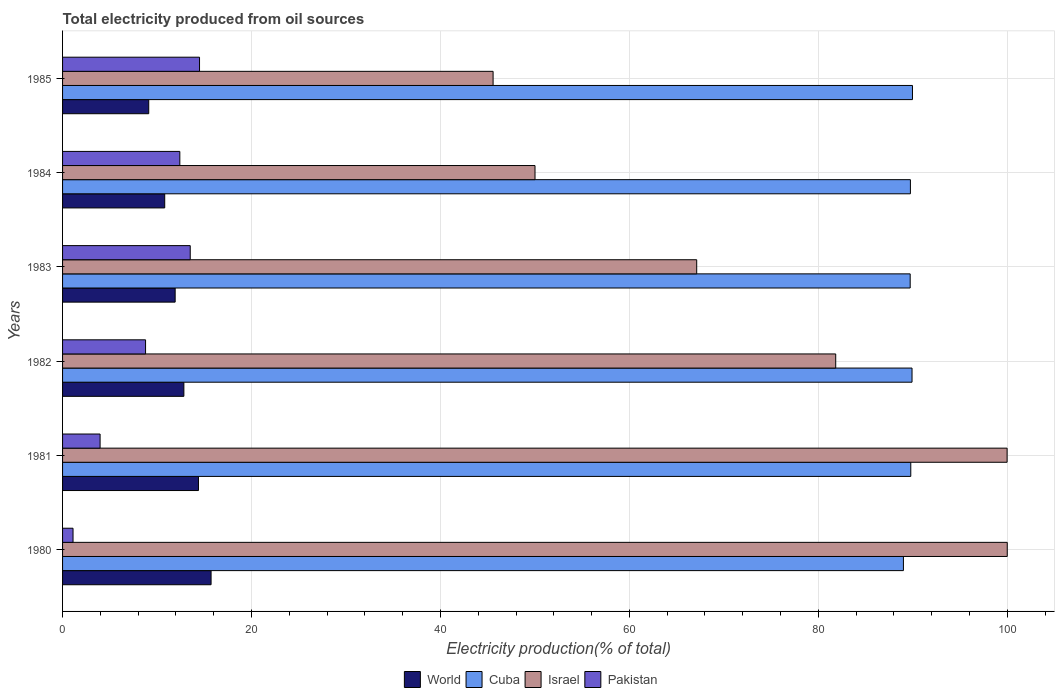How many different coloured bars are there?
Ensure brevity in your answer.  4. How many groups of bars are there?
Offer a terse response. 6. Are the number of bars on each tick of the Y-axis equal?
Your answer should be compact. Yes. How many bars are there on the 4th tick from the top?
Provide a succinct answer. 4. What is the total electricity produced in Israel in 1984?
Give a very brief answer. 50.01. Across all years, what is the maximum total electricity produced in World?
Your answer should be compact. 15.72. Across all years, what is the minimum total electricity produced in Pakistan?
Offer a very short reply. 1.11. In which year was the total electricity produced in Israel maximum?
Offer a terse response. 1980. In which year was the total electricity produced in World minimum?
Ensure brevity in your answer.  1985. What is the total total electricity produced in World in the graph?
Offer a very short reply. 74.8. What is the difference between the total electricity produced in Pakistan in 1983 and that in 1985?
Your response must be concise. -0.98. What is the difference between the total electricity produced in Israel in 1983 and the total electricity produced in Cuba in 1984?
Your response must be concise. -22.62. What is the average total electricity produced in Israel per year?
Provide a short and direct response. 74.09. In the year 1983, what is the difference between the total electricity produced in Israel and total electricity produced in World?
Provide a succinct answer. 55.21. What is the ratio of the total electricity produced in World in 1980 to that in 1982?
Provide a succinct answer. 1.22. Is the total electricity produced in Israel in 1981 less than that in 1982?
Provide a short and direct response. No. What is the difference between the highest and the second highest total electricity produced in Pakistan?
Give a very brief answer. 0.98. What is the difference between the highest and the lowest total electricity produced in Pakistan?
Offer a terse response. 13.39. In how many years, is the total electricity produced in World greater than the average total electricity produced in World taken over all years?
Offer a very short reply. 3. Is it the case that in every year, the sum of the total electricity produced in Pakistan and total electricity produced in World is greater than the sum of total electricity produced in Israel and total electricity produced in Cuba?
Offer a terse response. No. What does the 1st bar from the top in 1981 represents?
Offer a terse response. Pakistan. How many bars are there?
Your answer should be compact. 24. Are all the bars in the graph horizontal?
Give a very brief answer. Yes. Does the graph contain any zero values?
Provide a short and direct response. No. Does the graph contain grids?
Give a very brief answer. Yes. How are the legend labels stacked?
Your answer should be very brief. Horizontal. What is the title of the graph?
Your response must be concise. Total electricity produced from oil sources. Does "Tunisia" appear as one of the legend labels in the graph?
Provide a short and direct response. No. What is the Electricity production(% of total) in World in 1980?
Provide a succinct answer. 15.72. What is the Electricity production(% of total) of Cuba in 1980?
Make the answer very short. 89.01. What is the Electricity production(% of total) in Israel in 1980?
Your response must be concise. 100. What is the Electricity production(% of total) in Pakistan in 1980?
Offer a terse response. 1.11. What is the Electricity production(% of total) of World in 1981?
Your answer should be compact. 14.39. What is the Electricity production(% of total) in Cuba in 1981?
Provide a short and direct response. 89.79. What is the Electricity production(% of total) in Israel in 1981?
Ensure brevity in your answer.  99.98. What is the Electricity production(% of total) of Pakistan in 1981?
Keep it short and to the point. 3.97. What is the Electricity production(% of total) in World in 1982?
Your answer should be very brief. 12.84. What is the Electricity production(% of total) of Cuba in 1982?
Make the answer very short. 89.92. What is the Electricity production(% of total) in Israel in 1982?
Make the answer very short. 81.84. What is the Electricity production(% of total) of Pakistan in 1982?
Keep it short and to the point. 8.79. What is the Electricity production(% of total) of World in 1983?
Keep it short and to the point. 11.92. What is the Electricity production(% of total) in Cuba in 1983?
Offer a very short reply. 89.72. What is the Electricity production(% of total) of Israel in 1983?
Give a very brief answer. 67.13. What is the Electricity production(% of total) in Pakistan in 1983?
Offer a terse response. 13.51. What is the Electricity production(% of total) of World in 1984?
Your answer should be very brief. 10.81. What is the Electricity production(% of total) in Cuba in 1984?
Your response must be concise. 89.75. What is the Electricity production(% of total) in Israel in 1984?
Offer a very short reply. 50.01. What is the Electricity production(% of total) in Pakistan in 1984?
Your response must be concise. 12.41. What is the Electricity production(% of total) of World in 1985?
Your answer should be compact. 9.12. What is the Electricity production(% of total) in Cuba in 1985?
Keep it short and to the point. 89.97. What is the Electricity production(% of total) in Israel in 1985?
Your answer should be compact. 45.57. What is the Electricity production(% of total) in Pakistan in 1985?
Keep it short and to the point. 14.5. Across all years, what is the maximum Electricity production(% of total) of World?
Provide a short and direct response. 15.72. Across all years, what is the maximum Electricity production(% of total) of Cuba?
Provide a short and direct response. 89.97. Across all years, what is the maximum Electricity production(% of total) of Pakistan?
Your answer should be compact. 14.5. Across all years, what is the minimum Electricity production(% of total) of World?
Make the answer very short. 9.12. Across all years, what is the minimum Electricity production(% of total) of Cuba?
Your response must be concise. 89.01. Across all years, what is the minimum Electricity production(% of total) of Israel?
Give a very brief answer. 45.57. Across all years, what is the minimum Electricity production(% of total) of Pakistan?
Give a very brief answer. 1.11. What is the total Electricity production(% of total) in World in the graph?
Keep it short and to the point. 74.8. What is the total Electricity production(% of total) in Cuba in the graph?
Offer a terse response. 538.16. What is the total Electricity production(% of total) in Israel in the graph?
Provide a short and direct response. 444.54. What is the total Electricity production(% of total) of Pakistan in the graph?
Your response must be concise. 54.29. What is the difference between the Electricity production(% of total) of World in 1980 and that in 1981?
Your answer should be compact. 1.33. What is the difference between the Electricity production(% of total) in Cuba in 1980 and that in 1981?
Ensure brevity in your answer.  -0.78. What is the difference between the Electricity production(% of total) of Israel in 1980 and that in 1981?
Offer a very short reply. 0.02. What is the difference between the Electricity production(% of total) of Pakistan in 1980 and that in 1981?
Provide a short and direct response. -2.86. What is the difference between the Electricity production(% of total) of World in 1980 and that in 1982?
Offer a very short reply. 2.88. What is the difference between the Electricity production(% of total) of Cuba in 1980 and that in 1982?
Offer a very short reply. -0.91. What is the difference between the Electricity production(% of total) in Israel in 1980 and that in 1982?
Your answer should be very brief. 18.16. What is the difference between the Electricity production(% of total) of Pakistan in 1980 and that in 1982?
Give a very brief answer. -7.68. What is the difference between the Electricity production(% of total) in World in 1980 and that in 1983?
Offer a terse response. 3.8. What is the difference between the Electricity production(% of total) in Cuba in 1980 and that in 1983?
Provide a short and direct response. -0.72. What is the difference between the Electricity production(% of total) of Israel in 1980 and that in 1983?
Your answer should be very brief. 32.87. What is the difference between the Electricity production(% of total) of Pakistan in 1980 and that in 1983?
Your response must be concise. -12.41. What is the difference between the Electricity production(% of total) in World in 1980 and that in 1984?
Ensure brevity in your answer.  4.91. What is the difference between the Electricity production(% of total) of Cuba in 1980 and that in 1984?
Your answer should be compact. -0.74. What is the difference between the Electricity production(% of total) in Israel in 1980 and that in 1984?
Keep it short and to the point. 49.99. What is the difference between the Electricity production(% of total) in Pakistan in 1980 and that in 1984?
Your response must be concise. -11.3. What is the difference between the Electricity production(% of total) of World in 1980 and that in 1985?
Your answer should be compact. 6.6. What is the difference between the Electricity production(% of total) in Cuba in 1980 and that in 1985?
Offer a very short reply. -0.96. What is the difference between the Electricity production(% of total) of Israel in 1980 and that in 1985?
Offer a terse response. 54.43. What is the difference between the Electricity production(% of total) in Pakistan in 1980 and that in 1985?
Your answer should be compact. -13.39. What is the difference between the Electricity production(% of total) of World in 1981 and that in 1982?
Offer a very short reply. 1.55. What is the difference between the Electricity production(% of total) in Cuba in 1981 and that in 1982?
Give a very brief answer. -0.13. What is the difference between the Electricity production(% of total) of Israel in 1981 and that in 1982?
Provide a succinct answer. 18.14. What is the difference between the Electricity production(% of total) in Pakistan in 1981 and that in 1982?
Your answer should be very brief. -4.81. What is the difference between the Electricity production(% of total) in World in 1981 and that in 1983?
Make the answer very short. 2.47. What is the difference between the Electricity production(% of total) in Cuba in 1981 and that in 1983?
Ensure brevity in your answer.  0.06. What is the difference between the Electricity production(% of total) in Israel in 1981 and that in 1983?
Your answer should be compact. 32.86. What is the difference between the Electricity production(% of total) of Pakistan in 1981 and that in 1983?
Make the answer very short. -9.54. What is the difference between the Electricity production(% of total) of World in 1981 and that in 1984?
Keep it short and to the point. 3.57. What is the difference between the Electricity production(% of total) of Cuba in 1981 and that in 1984?
Provide a short and direct response. 0.04. What is the difference between the Electricity production(% of total) in Israel in 1981 and that in 1984?
Offer a terse response. 49.97. What is the difference between the Electricity production(% of total) of Pakistan in 1981 and that in 1984?
Provide a succinct answer. -8.44. What is the difference between the Electricity production(% of total) in World in 1981 and that in 1985?
Your response must be concise. 5.27. What is the difference between the Electricity production(% of total) in Cuba in 1981 and that in 1985?
Your answer should be very brief. -0.18. What is the difference between the Electricity production(% of total) of Israel in 1981 and that in 1985?
Your answer should be very brief. 54.41. What is the difference between the Electricity production(% of total) in Pakistan in 1981 and that in 1985?
Provide a succinct answer. -10.53. What is the difference between the Electricity production(% of total) in World in 1982 and that in 1983?
Your answer should be very brief. 0.92. What is the difference between the Electricity production(% of total) of Cuba in 1982 and that in 1983?
Your answer should be very brief. 0.2. What is the difference between the Electricity production(% of total) in Israel in 1982 and that in 1983?
Provide a short and direct response. 14.72. What is the difference between the Electricity production(% of total) in Pakistan in 1982 and that in 1983?
Ensure brevity in your answer.  -4.73. What is the difference between the Electricity production(% of total) of World in 1982 and that in 1984?
Keep it short and to the point. 2.03. What is the difference between the Electricity production(% of total) in Cuba in 1982 and that in 1984?
Ensure brevity in your answer.  0.17. What is the difference between the Electricity production(% of total) of Israel in 1982 and that in 1984?
Give a very brief answer. 31.83. What is the difference between the Electricity production(% of total) in Pakistan in 1982 and that in 1984?
Give a very brief answer. -3.63. What is the difference between the Electricity production(% of total) of World in 1982 and that in 1985?
Give a very brief answer. 3.72. What is the difference between the Electricity production(% of total) of Cuba in 1982 and that in 1985?
Your answer should be compact. -0.05. What is the difference between the Electricity production(% of total) in Israel in 1982 and that in 1985?
Make the answer very short. 36.27. What is the difference between the Electricity production(% of total) in Pakistan in 1982 and that in 1985?
Offer a very short reply. -5.71. What is the difference between the Electricity production(% of total) in World in 1983 and that in 1984?
Your response must be concise. 1.1. What is the difference between the Electricity production(% of total) in Cuba in 1983 and that in 1984?
Provide a succinct answer. -0.02. What is the difference between the Electricity production(% of total) in Israel in 1983 and that in 1984?
Make the answer very short. 17.12. What is the difference between the Electricity production(% of total) of Pakistan in 1983 and that in 1984?
Make the answer very short. 1.1. What is the difference between the Electricity production(% of total) in World in 1983 and that in 1985?
Keep it short and to the point. 2.8. What is the difference between the Electricity production(% of total) in Cuba in 1983 and that in 1985?
Your answer should be compact. -0.24. What is the difference between the Electricity production(% of total) in Israel in 1983 and that in 1985?
Provide a succinct answer. 21.55. What is the difference between the Electricity production(% of total) in Pakistan in 1983 and that in 1985?
Make the answer very short. -0.98. What is the difference between the Electricity production(% of total) of World in 1984 and that in 1985?
Provide a succinct answer. 1.69. What is the difference between the Electricity production(% of total) of Cuba in 1984 and that in 1985?
Provide a succinct answer. -0.22. What is the difference between the Electricity production(% of total) in Israel in 1984 and that in 1985?
Your answer should be very brief. 4.44. What is the difference between the Electricity production(% of total) of Pakistan in 1984 and that in 1985?
Give a very brief answer. -2.09. What is the difference between the Electricity production(% of total) of World in 1980 and the Electricity production(% of total) of Cuba in 1981?
Your answer should be very brief. -74.07. What is the difference between the Electricity production(% of total) in World in 1980 and the Electricity production(% of total) in Israel in 1981?
Provide a succinct answer. -84.26. What is the difference between the Electricity production(% of total) of World in 1980 and the Electricity production(% of total) of Pakistan in 1981?
Offer a terse response. 11.75. What is the difference between the Electricity production(% of total) of Cuba in 1980 and the Electricity production(% of total) of Israel in 1981?
Give a very brief answer. -10.98. What is the difference between the Electricity production(% of total) of Cuba in 1980 and the Electricity production(% of total) of Pakistan in 1981?
Ensure brevity in your answer.  85.04. What is the difference between the Electricity production(% of total) in Israel in 1980 and the Electricity production(% of total) in Pakistan in 1981?
Your response must be concise. 96.03. What is the difference between the Electricity production(% of total) in World in 1980 and the Electricity production(% of total) in Cuba in 1982?
Keep it short and to the point. -74.2. What is the difference between the Electricity production(% of total) in World in 1980 and the Electricity production(% of total) in Israel in 1982?
Give a very brief answer. -66.12. What is the difference between the Electricity production(% of total) of World in 1980 and the Electricity production(% of total) of Pakistan in 1982?
Ensure brevity in your answer.  6.94. What is the difference between the Electricity production(% of total) of Cuba in 1980 and the Electricity production(% of total) of Israel in 1982?
Offer a terse response. 7.17. What is the difference between the Electricity production(% of total) of Cuba in 1980 and the Electricity production(% of total) of Pakistan in 1982?
Offer a terse response. 80.22. What is the difference between the Electricity production(% of total) of Israel in 1980 and the Electricity production(% of total) of Pakistan in 1982?
Your response must be concise. 91.21. What is the difference between the Electricity production(% of total) of World in 1980 and the Electricity production(% of total) of Cuba in 1983?
Provide a succinct answer. -74. What is the difference between the Electricity production(% of total) of World in 1980 and the Electricity production(% of total) of Israel in 1983?
Offer a terse response. -51.41. What is the difference between the Electricity production(% of total) of World in 1980 and the Electricity production(% of total) of Pakistan in 1983?
Keep it short and to the point. 2.21. What is the difference between the Electricity production(% of total) in Cuba in 1980 and the Electricity production(% of total) in Israel in 1983?
Keep it short and to the point. 21.88. What is the difference between the Electricity production(% of total) in Cuba in 1980 and the Electricity production(% of total) in Pakistan in 1983?
Your answer should be compact. 75.49. What is the difference between the Electricity production(% of total) in Israel in 1980 and the Electricity production(% of total) in Pakistan in 1983?
Keep it short and to the point. 86.49. What is the difference between the Electricity production(% of total) in World in 1980 and the Electricity production(% of total) in Cuba in 1984?
Give a very brief answer. -74.03. What is the difference between the Electricity production(% of total) of World in 1980 and the Electricity production(% of total) of Israel in 1984?
Ensure brevity in your answer.  -34.29. What is the difference between the Electricity production(% of total) in World in 1980 and the Electricity production(% of total) in Pakistan in 1984?
Offer a terse response. 3.31. What is the difference between the Electricity production(% of total) in Cuba in 1980 and the Electricity production(% of total) in Israel in 1984?
Offer a very short reply. 39. What is the difference between the Electricity production(% of total) in Cuba in 1980 and the Electricity production(% of total) in Pakistan in 1984?
Offer a terse response. 76.6. What is the difference between the Electricity production(% of total) of Israel in 1980 and the Electricity production(% of total) of Pakistan in 1984?
Keep it short and to the point. 87.59. What is the difference between the Electricity production(% of total) in World in 1980 and the Electricity production(% of total) in Cuba in 1985?
Your answer should be very brief. -74.25. What is the difference between the Electricity production(% of total) of World in 1980 and the Electricity production(% of total) of Israel in 1985?
Make the answer very short. -29.85. What is the difference between the Electricity production(% of total) in World in 1980 and the Electricity production(% of total) in Pakistan in 1985?
Give a very brief answer. 1.22. What is the difference between the Electricity production(% of total) in Cuba in 1980 and the Electricity production(% of total) in Israel in 1985?
Provide a short and direct response. 43.43. What is the difference between the Electricity production(% of total) in Cuba in 1980 and the Electricity production(% of total) in Pakistan in 1985?
Your response must be concise. 74.51. What is the difference between the Electricity production(% of total) in Israel in 1980 and the Electricity production(% of total) in Pakistan in 1985?
Keep it short and to the point. 85.5. What is the difference between the Electricity production(% of total) in World in 1981 and the Electricity production(% of total) in Cuba in 1982?
Your answer should be very brief. -75.53. What is the difference between the Electricity production(% of total) in World in 1981 and the Electricity production(% of total) in Israel in 1982?
Provide a succinct answer. -67.46. What is the difference between the Electricity production(% of total) in World in 1981 and the Electricity production(% of total) in Pakistan in 1982?
Offer a terse response. 5.6. What is the difference between the Electricity production(% of total) in Cuba in 1981 and the Electricity production(% of total) in Israel in 1982?
Offer a terse response. 7.95. What is the difference between the Electricity production(% of total) in Cuba in 1981 and the Electricity production(% of total) in Pakistan in 1982?
Make the answer very short. 81. What is the difference between the Electricity production(% of total) of Israel in 1981 and the Electricity production(% of total) of Pakistan in 1982?
Make the answer very short. 91.2. What is the difference between the Electricity production(% of total) in World in 1981 and the Electricity production(% of total) in Cuba in 1983?
Keep it short and to the point. -75.34. What is the difference between the Electricity production(% of total) in World in 1981 and the Electricity production(% of total) in Israel in 1983?
Your answer should be very brief. -52.74. What is the difference between the Electricity production(% of total) in World in 1981 and the Electricity production(% of total) in Pakistan in 1983?
Make the answer very short. 0.87. What is the difference between the Electricity production(% of total) in Cuba in 1981 and the Electricity production(% of total) in Israel in 1983?
Make the answer very short. 22.66. What is the difference between the Electricity production(% of total) in Cuba in 1981 and the Electricity production(% of total) in Pakistan in 1983?
Your answer should be very brief. 76.27. What is the difference between the Electricity production(% of total) in Israel in 1981 and the Electricity production(% of total) in Pakistan in 1983?
Make the answer very short. 86.47. What is the difference between the Electricity production(% of total) in World in 1981 and the Electricity production(% of total) in Cuba in 1984?
Provide a succinct answer. -75.36. What is the difference between the Electricity production(% of total) in World in 1981 and the Electricity production(% of total) in Israel in 1984?
Your response must be concise. -35.62. What is the difference between the Electricity production(% of total) of World in 1981 and the Electricity production(% of total) of Pakistan in 1984?
Your answer should be very brief. 1.97. What is the difference between the Electricity production(% of total) in Cuba in 1981 and the Electricity production(% of total) in Israel in 1984?
Provide a short and direct response. 39.78. What is the difference between the Electricity production(% of total) of Cuba in 1981 and the Electricity production(% of total) of Pakistan in 1984?
Provide a short and direct response. 77.37. What is the difference between the Electricity production(% of total) of Israel in 1981 and the Electricity production(% of total) of Pakistan in 1984?
Provide a short and direct response. 87.57. What is the difference between the Electricity production(% of total) of World in 1981 and the Electricity production(% of total) of Cuba in 1985?
Offer a very short reply. -75.58. What is the difference between the Electricity production(% of total) of World in 1981 and the Electricity production(% of total) of Israel in 1985?
Make the answer very short. -31.19. What is the difference between the Electricity production(% of total) in World in 1981 and the Electricity production(% of total) in Pakistan in 1985?
Provide a succinct answer. -0.11. What is the difference between the Electricity production(% of total) of Cuba in 1981 and the Electricity production(% of total) of Israel in 1985?
Offer a terse response. 44.21. What is the difference between the Electricity production(% of total) of Cuba in 1981 and the Electricity production(% of total) of Pakistan in 1985?
Offer a terse response. 75.29. What is the difference between the Electricity production(% of total) in Israel in 1981 and the Electricity production(% of total) in Pakistan in 1985?
Your answer should be compact. 85.49. What is the difference between the Electricity production(% of total) of World in 1982 and the Electricity production(% of total) of Cuba in 1983?
Make the answer very short. -76.88. What is the difference between the Electricity production(% of total) of World in 1982 and the Electricity production(% of total) of Israel in 1983?
Make the answer very short. -54.29. What is the difference between the Electricity production(% of total) in World in 1982 and the Electricity production(% of total) in Pakistan in 1983?
Provide a succinct answer. -0.67. What is the difference between the Electricity production(% of total) in Cuba in 1982 and the Electricity production(% of total) in Israel in 1983?
Your answer should be compact. 22.79. What is the difference between the Electricity production(% of total) in Cuba in 1982 and the Electricity production(% of total) in Pakistan in 1983?
Provide a short and direct response. 76.41. What is the difference between the Electricity production(% of total) in Israel in 1982 and the Electricity production(% of total) in Pakistan in 1983?
Give a very brief answer. 68.33. What is the difference between the Electricity production(% of total) of World in 1982 and the Electricity production(% of total) of Cuba in 1984?
Make the answer very short. -76.91. What is the difference between the Electricity production(% of total) of World in 1982 and the Electricity production(% of total) of Israel in 1984?
Offer a very short reply. -37.17. What is the difference between the Electricity production(% of total) in World in 1982 and the Electricity production(% of total) in Pakistan in 1984?
Ensure brevity in your answer.  0.43. What is the difference between the Electricity production(% of total) in Cuba in 1982 and the Electricity production(% of total) in Israel in 1984?
Keep it short and to the point. 39.91. What is the difference between the Electricity production(% of total) in Cuba in 1982 and the Electricity production(% of total) in Pakistan in 1984?
Your response must be concise. 77.51. What is the difference between the Electricity production(% of total) in Israel in 1982 and the Electricity production(% of total) in Pakistan in 1984?
Make the answer very short. 69.43. What is the difference between the Electricity production(% of total) of World in 1982 and the Electricity production(% of total) of Cuba in 1985?
Keep it short and to the point. -77.13. What is the difference between the Electricity production(% of total) in World in 1982 and the Electricity production(% of total) in Israel in 1985?
Provide a succinct answer. -32.73. What is the difference between the Electricity production(% of total) of World in 1982 and the Electricity production(% of total) of Pakistan in 1985?
Give a very brief answer. -1.66. What is the difference between the Electricity production(% of total) of Cuba in 1982 and the Electricity production(% of total) of Israel in 1985?
Offer a very short reply. 44.35. What is the difference between the Electricity production(% of total) of Cuba in 1982 and the Electricity production(% of total) of Pakistan in 1985?
Ensure brevity in your answer.  75.42. What is the difference between the Electricity production(% of total) of Israel in 1982 and the Electricity production(% of total) of Pakistan in 1985?
Your answer should be very brief. 67.34. What is the difference between the Electricity production(% of total) of World in 1983 and the Electricity production(% of total) of Cuba in 1984?
Provide a short and direct response. -77.83. What is the difference between the Electricity production(% of total) of World in 1983 and the Electricity production(% of total) of Israel in 1984?
Ensure brevity in your answer.  -38.09. What is the difference between the Electricity production(% of total) in World in 1983 and the Electricity production(% of total) in Pakistan in 1984?
Offer a very short reply. -0.49. What is the difference between the Electricity production(% of total) in Cuba in 1983 and the Electricity production(% of total) in Israel in 1984?
Make the answer very short. 39.71. What is the difference between the Electricity production(% of total) of Cuba in 1983 and the Electricity production(% of total) of Pakistan in 1984?
Offer a very short reply. 77.31. What is the difference between the Electricity production(% of total) of Israel in 1983 and the Electricity production(% of total) of Pakistan in 1984?
Provide a succinct answer. 54.71. What is the difference between the Electricity production(% of total) of World in 1983 and the Electricity production(% of total) of Cuba in 1985?
Offer a terse response. -78.05. What is the difference between the Electricity production(% of total) of World in 1983 and the Electricity production(% of total) of Israel in 1985?
Offer a very short reply. -33.66. What is the difference between the Electricity production(% of total) of World in 1983 and the Electricity production(% of total) of Pakistan in 1985?
Ensure brevity in your answer.  -2.58. What is the difference between the Electricity production(% of total) in Cuba in 1983 and the Electricity production(% of total) in Israel in 1985?
Your answer should be compact. 44.15. What is the difference between the Electricity production(% of total) of Cuba in 1983 and the Electricity production(% of total) of Pakistan in 1985?
Your response must be concise. 75.23. What is the difference between the Electricity production(% of total) of Israel in 1983 and the Electricity production(% of total) of Pakistan in 1985?
Your answer should be very brief. 52.63. What is the difference between the Electricity production(% of total) of World in 1984 and the Electricity production(% of total) of Cuba in 1985?
Your answer should be very brief. -79.15. What is the difference between the Electricity production(% of total) of World in 1984 and the Electricity production(% of total) of Israel in 1985?
Offer a very short reply. -34.76. What is the difference between the Electricity production(% of total) of World in 1984 and the Electricity production(% of total) of Pakistan in 1985?
Your answer should be compact. -3.68. What is the difference between the Electricity production(% of total) of Cuba in 1984 and the Electricity production(% of total) of Israel in 1985?
Offer a very short reply. 44.17. What is the difference between the Electricity production(% of total) of Cuba in 1984 and the Electricity production(% of total) of Pakistan in 1985?
Provide a succinct answer. 75.25. What is the difference between the Electricity production(% of total) in Israel in 1984 and the Electricity production(% of total) in Pakistan in 1985?
Your answer should be very brief. 35.51. What is the average Electricity production(% of total) in World per year?
Keep it short and to the point. 12.47. What is the average Electricity production(% of total) in Cuba per year?
Offer a very short reply. 89.69. What is the average Electricity production(% of total) of Israel per year?
Provide a short and direct response. 74.09. What is the average Electricity production(% of total) in Pakistan per year?
Give a very brief answer. 9.05. In the year 1980, what is the difference between the Electricity production(% of total) of World and Electricity production(% of total) of Cuba?
Give a very brief answer. -73.29. In the year 1980, what is the difference between the Electricity production(% of total) in World and Electricity production(% of total) in Israel?
Make the answer very short. -84.28. In the year 1980, what is the difference between the Electricity production(% of total) in World and Electricity production(% of total) in Pakistan?
Offer a terse response. 14.61. In the year 1980, what is the difference between the Electricity production(% of total) of Cuba and Electricity production(% of total) of Israel?
Offer a very short reply. -10.99. In the year 1980, what is the difference between the Electricity production(% of total) of Cuba and Electricity production(% of total) of Pakistan?
Provide a short and direct response. 87.9. In the year 1980, what is the difference between the Electricity production(% of total) in Israel and Electricity production(% of total) in Pakistan?
Provide a short and direct response. 98.89. In the year 1981, what is the difference between the Electricity production(% of total) in World and Electricity production(% of total) in Cuba?
Your response must be concise. -75.4. In the year 1981, what is the difference between the Electricity production(% of total) in World and Electricity production(% of total) in Israel?
Provide a short and direct response. -85.6. In the year 1981, what is the difference between the Electricity production(% of total) in World and Electricity production(% of total) in Pakistan?
Provide a succinct answer. 10.41. In the year 1981, what is the difference between the Electricity production(% of total) in Cuba and Electricity production(% of total) in Israel?
Make the answer very short. -10.2. In the year 1981, what is the difference between the Electricity production(% of total) of Cuba and Electricity production(% of total) of Pakistan?
Ensure brevity in your answer.  85.82. In the year 1981, what is the difference between the Electricity production(% of total) in Israel and Electricity production(% of total) in Pakistan?
Provide a succinct answer. 96.01. In the year 1982, what is the difference between the Electricity production(% of total) in World and Electricity production(% of total) in Cuba?
Your answer should be very brief. -77.08. In the year 1982, what is the difference between the Electricity production(% of total) of World and Electricity production(% of total) of Israel?
Provide a succinct answer. -69. In the year 1982, what is the difference between the Electricity production(% of total) in World and Electricity production(% of total) in Pakistan?
Give a very brief answer. 4.05. In the year 1982, what is the difference between the Electricity production(% of total) of Cuba and Electricity production(% of total) of Israel?
Give a very brief answer. 8.08. In the year 1982, what is the difference between the Electricity production(% of total) in Cuba and Electricity production(% of total) in Pakistan?
Offer a very short reply. 81.13. In the year 1982, what is the difference between the Electricity production(% of total) in Israel and Electricity production(% of total) in Pakistan?
Your answer should be very brief. 73.06. In the year 1983, what is the difference between the Electricity production(% of total) of World and Electricity production(% of total) of Cuba?
Provide a short and direct response. -77.81. In the year 1983, what is the difference between the Electricity production(% of total) in World and Electricity production(% of total) in Israel?
Provide a short and direct response. -55.21. In the year 1983, what is the difference between the Electricity production(% of total) in World and Electricity production(% of total) in Pakistan?
Offer a very short reply. -1.6. In the year 1983, what is the difference between the Electricity production(% of total) in Cuba and Electricity production(% of total) in Israel?
Your answer should be compact. 22.6. In the year 1983, what is the difference between the Electricity production(% of total) of Cuba and Electricity production(% of total) of Pakistan?
Make the answer very short. 76.21. In the year 1983, what is the difference between the Electricity production(% of total) of Israel and Electricity production(% of total) of Pakistan?
Offer a very short reply. 53.61. In the year 1984, what is the difference between the Electricity production(% of total) of World and Electricity production(% of total) of Cuba?
Your answer should be compact. -78.93. In the year 1984, what is the difference between the Electricity production(% of total) in World and Electricity production(% of total) in Israel?
Offer a terse response. -39.2. In the year 1984, what is the difference between the Electricity production(% of total) in World and Electricity production(% of total) in Pakistan?
Make the answer very short. -1.6. In the year 1984, what is the difference between the Electricity production(% of total) of Cuba and Electricity production(% of total) of Israel?
Offer a terse response. 39.74. In the year 1984, what is the difference between the Electricity production(% of total) in Cuba and Electricity production(% of total) in Pakistan?
Provide a succinct answer. 77.34. In the year 1984, what is the difference between the Electricity production(% of total) in Israel and Electricity production(% of total) in Pakistan?
Keep it short and to the point. 37.6. In the year 1985, what is the difference between the Electricity production(% of total) of World and Electricity production(% of total) of Cuba?
Make the answer very short. -80.85. In the year 1985, what is the difference between the Electricity production(% of total) of World and Electricity production(% of total) of Israel?
Your answer should be very brief. -36.45. In the year 1985, what is the difference between the Electricity production(% of total) in World and Electricity production(% of total) in Pakistan?
Make the answer very short. -5.38. In the year 1985, what is the difference between the Electricity production(% of total) of Cuba and Electricity production(% of total) of Israel?
Offer a terse response. 44.39. In the year 1985, what is the difference between the Electricity production(% of total) in Cuba and Electricity production(% of total) in Pakistan?
Your answer should be compact. 75.47. In the year 1985, what is the difference between the Electricity production(% of total) in Israel and Electricity production(% of total) in Pakistan?
Provide a succinct answer. 31.08. What is the ratio of the Electricity production(% of total) in World in 1980 to that in 1981?
Give a very brief answer. 1.09. What is the ratio of the Electricity production(% of total) in Cuba in 1980 to that in 1981?
Your response must be concise. 0.99. What is the ratio of the Electricity production(% of total) of Israel in 1980 to that in 1981?
Make the answer very short. 1. What is the ratio of the Electricity production(% of total) in Pakistan in 1980 to that in 1981?
Make the answer very short. 0.28. What is the ratio of the Electricity production(% of total) of World in 1980 to that in 1982?
Your response must be concise. 1.22. What is the ratio of the Electricity production(% of total) of Cuba in 1980 to that in 1982?
Give a very brief answer. 0.99. What is the ratio of the Electricity production(% of total) of Israel in 1980 to that in 1982?
Provide a short and direct response. 1.22. What is the ratio of the Electricity production(% of total) in Pakistan in 1980 to that in 1982?
Offer a very short reply. 0.13. What is the ratio of the Electricity production(% of total) of World in 1980 to that in 1983?
Offer a terse response. 1.32. What is the ratio of the Electricity production(% of total) of Cuba in 1980 to that in 1983?
Provide a succinct answer. 0.99. What is the ratio of the Electricity production(% of total) of Israel in 1980 to that in 1983?
Your response must be concise. 1.49. What is the ratio of the Electricity production(% of total) of Pakistan in 1980 to that in 1983?
Make the answer very short. 0.08. What is the ratio of the Electricity production(% of total) in World in 1980 to that in 1984?
Your response must be concise. 1.45. What is the ratio of the Electricity production(% of total) in Cuba in 1980 to that in 1984?
Offer a terse response. 0.99. What is the ratio of the Electricity production(% of total) in Israel in 1980 to that in 1984?
Give a very brief answer. 2. What is the ratio of the Electricity production(% of total) of Pakistan in 1980 to that in 1984?
Keep it short and to the point. 0.09. What is the ratio of the Electricity production(% of total) in World in 1980 to that in 1985?
Your answer should be very brief. 1.72. What is the ratio of the Electricity production(% of total) in Cuba in 1980 to that in 1985?
Make the answer very short. 0.99. What is the ratio of the Electricity production(% of total) in Israel in 1980 to that in 1985?
Offer a terse response. 2.19. What is the ratio of the Electricity production(% of total) in Pakistan in 1980 to that in 1985?
Ensure brevity in your answer.  0.08. What is the ratio of the Electricity production(% of total) in World in 1981 to that in 1982?
Offer a terse response. 1.12. What is the ratio of the Electricity production(% of total) of Cuba in 1981 to that in 1982?
Your answer should be compact. 1. What is the ratio of the Electricity production(% of total) in Israel in 1981 to that in 1982?
Offer a terse response. 1.22. What is the ratio of the Electricity production(% of total) in Pakistan in 1981 to that in 1982?
Offer a very short reply. 0.45. What is the ratio of the Electricity production(% of total) of World in 1981 to that in 1983?
Ensure brevity in your answer.  1.21. What is the ratio of the Electricity production(% of total) of Cuba in 1981 to that in 1983?
Provide a short and direct response. 1. What is the ratio of the Electricity production(% of total) in Israel in 1981 to that in 1983?
Your answer should be compact. 1.49. What is the ratio of the Electricity production(% of total) of Pakistan in 1981 to that in 1983?
Offer a terse response. 0.29. What is the ratio of the Electricity production(% of total) in World in 1981 to that in 1984?
Your answer should be compact. 1.33. What is the ratio of the Electricity production(% of total) of Cuba in 1981 to that in 1984?
Your answer should be compact. 1. What is the ratio of the Electricity production(% of total) in Israel in 1981 to that in 1984?
Provide a short and direct response. 2. What is the ratio of the Electricity production(% of total) of Pakistan in 1981 to that in 1984?
Provide a succinct answer. 0.32. What is the ratio of the Electricity production(% of total) in World in 1981 to that in 1985?
Give a very brief answer. 1.58. What is the ratio of the Electricity production(% of total) of Cuba in 1981 to that in 1985?
Offer a terse response. 1. What is the ratio of the Electricity production(% of total) of Israel in 1981 to that in 1985?
Ensure brevity in your answer.  2.19. What is the ratio of the Electricity production(% of total) of Pakistan in 1981 to that in 1985?
Your answer should be compact. 0.27. What is the ratio of the Electricity production(% of total) in World in 1982 to that in 1983?
Offer a very short reply. 1.08. What is the ratio of the Electricity production(% of total) of Cuba in 1982 to that in 1983?
Offer a very short reply. 1. What is the ratio of the Electricity production(% of total) of Israel in 1982 to that in 1983?
Make the answer very short. 1.22. What is the ratio of the Electricity production(% of total) of Pakistan in 1982 to that in 1983?
Make the answer very short. 0.65. What is the ratio of the Electricity production(% of total) in World in 1982 to that in 1984?
Your answer should be very brief. 1.19. What is the ratio of the Electricity production(% of total) of Cuba in 1982 to that in 1984?
Your answer should be compact. 1. What is the ratio of the Electricity production(% of total) in Israel in 1982 to that in 1984?
Provide a short and direct response. 1.64. What is the ratio of the Electricity production(% of total) in Pakistan in 1982 to that in 1984?
Your answer should be very brief. 0.71. What is the ratio of the Electricity production(% of total) of World in 1982 to that in 1985?
Offer a very short reply. 1.41. What is the ratio of the Electricity production(% of total) in Cuba in 1982 to that in 1985?
Your answer should be compact. 1. What is the ratio of the Electricity production(% of total) in Israel in 1982 to that in 1985?
Your response must be concise. 1.8. What is the ratio of the Electricity production(% of total) of Pakistan in 1982 to that in 1985?
Provide a short and direct response. 0.61. What is the ratio of the Electricity production(% of total) of World in 1983 to that in 1984?
Your response must be concise. 1.1. What is the ratio of the Electricity production(% of total) of Israel in 1983 to that in 1984?
Offer a very short reply. 1.34. What is the ratio of the Electricity production(% of total) of Pakistan in 1983 to that in 1984?
Provide a short and direct response. 1.09. What is the ratio of the Electricity production(% of total) of World in 1983 to that in 1985?
Give a very brief answer. 1.31. What is the ratio of the Electricity production(% of total) of Israel in 1983 to that in 1985?
Your answer should be compact. 1.47. What is the ratio of the Electricity production(% of total) of Pakistan in 1983 to that in 1985?
Keep it short and to the point. 0.93. What is the ratio of the Electricity production(% of total) in World in 1984 to that in 1985?
Offer a very short reply. 1.19. What is the ratio of the Electricity production(% of total) of Israel in 1984 to that in 1985?
Keep it short and to the point. 1.1. What is the ratio of the Electricity production(% of total) of Pakistan in 1984 to that in 1985?
Your response must be concise. 0.86. What is the difference between the highest and the second highest Electricity production(% of total) in World?
Provide a succinct answer. 1.33. What is the difference between the highest and the second highest Electricity production(% of total) in Cuba?
Give a very brief answer. 0.05. What is the difference between the highest and the second highest Electricity production(% of total) of Israel?
Provide a short and direct response. 0.02. What is the difference between the highest and the second highest Electricity production(% of total) of Pakistan?
Provide a short and direct response. 0.98. What is the difference between the highest and the lowest Electricity production(% of total) of World?
Make the answer very short. 6.6. What is the difference between the highest and the lowest Electricity production(% of total) in Cuba?
Keep it short and to the point. 0.96. What is the difference between the highest and the lowest Electricity production(% of total) in Israel?
Ensure brevity in your answer.  54.43. What is the difference between the highest and the lowest Electricity production(% of total) in Pakistan?
Your response must be concise. 13.39. 